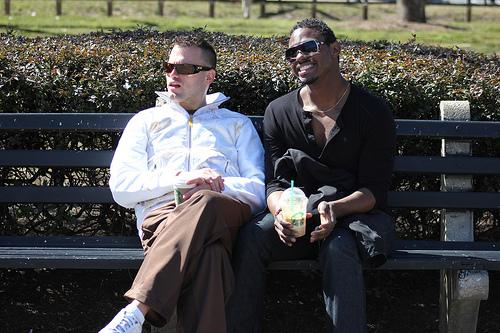Describe the interaction between the two main characters in the image. The two men appear to be conversing casually as they sit close together on the bench, looking in the same direction. Summarize the image in a single sentence. Two men wearing sunglasses are sitting and conversing on a park bench, with one holding a beverage. Explain the clothing worn by the subjects in the image. One man is wearing a white zipper jacket and the other is wearing a black long sleeve shirt, both have on sunglasses. What are the key elements in the image, and what is the setting? Key elements are two people on a bench, sunglasses, a beverage container, and a jacket. The setting is an outdoor park during the day. Describe any notable facial features or accessories observed in the image. One man has a black goatee, and both men are wearing sunglasses. Provide a brief description of the scene portrayed in the image. Two men, wearing sunglasses and sitting on a black park bench, are casually chatting while one of them enjoys a beverage from a plastic cup. Identify the type of environment surrounding the subjects and describe its features. The environment is an outdoor park with a grassy area, hedges, trees, and a fence in the background. Mention the key props and their positions in the image. A plastic beverage container is being held by one man, near his lap, while the other has a jacket resting on his. Examine the spatial relationship between the subjects in the image and any notable objects around them. The two men are sitting closely on a bench near the edge of a grassy field, with hedges and a fence visible in the distance. Discuss the posture and body language of the individuals in the image. One man is crossing his legs, and the other has his arms crossed while they both sit on the bench, engaged in conversation. 